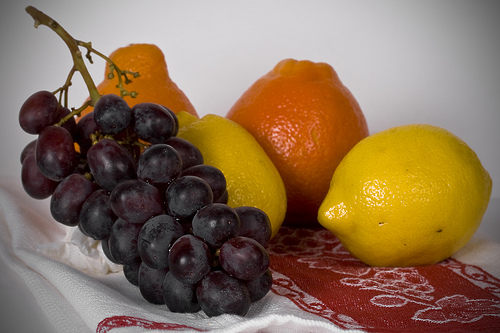<image>
Is the grapes behind the lemon? No. The grapes is not behind the lemon. From this viewpoint, the grapes appears to be positioned elsewhere in the scene. Is there a grape under the orange? No. The grape is not positioned under the orange. The vertical relationship between these objects is different. 